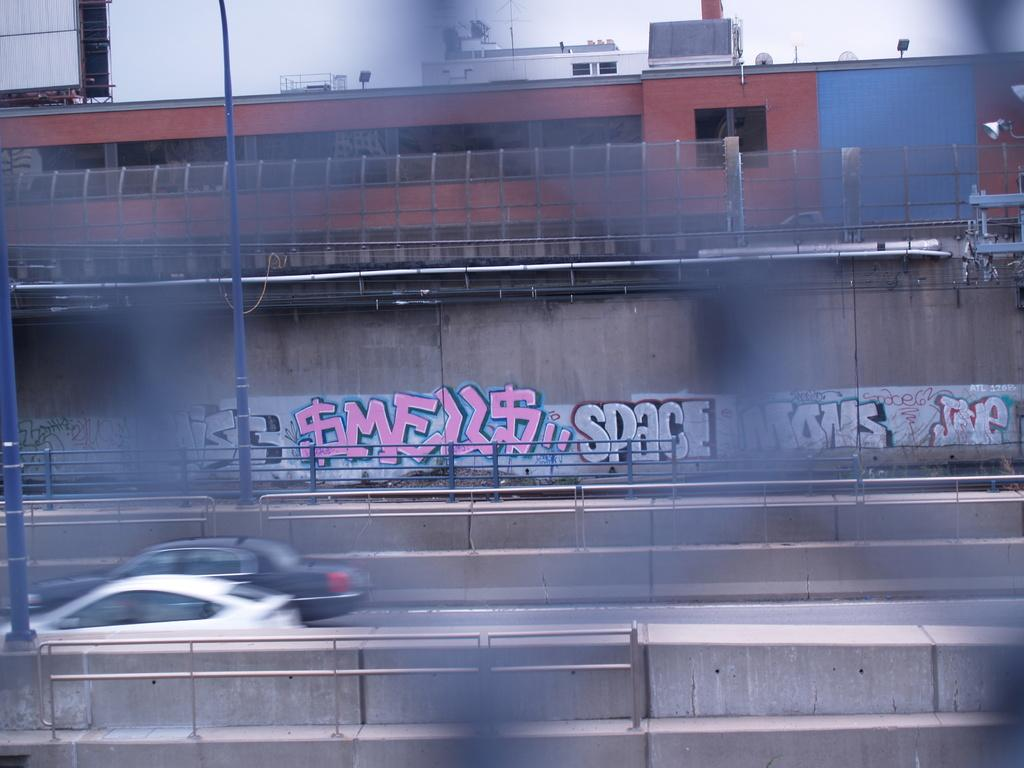<image>
Provide a brief description of the given image. An urban wall seen through a chain-link fence has graffiti on it that reads $mell$. 